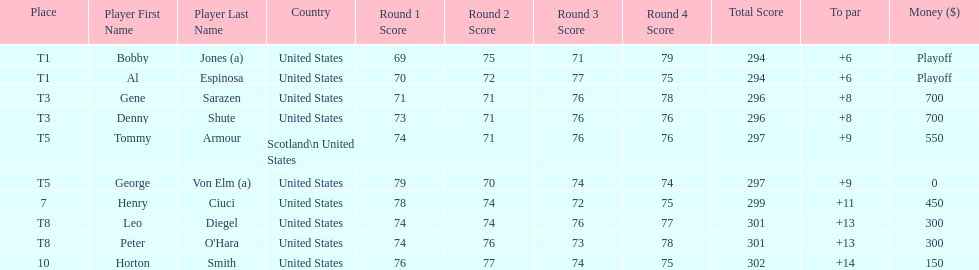Who was the last player in the top 10? Horton Smith. 